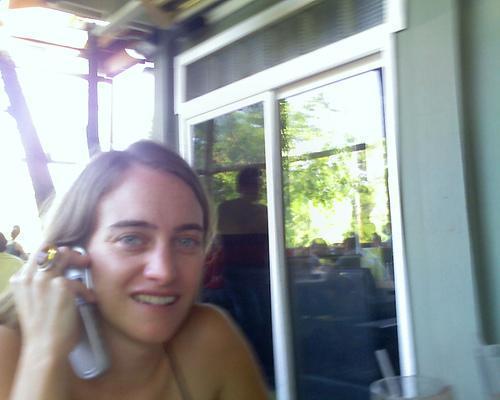Where is she most likely having a conversation on her cellphone?
Choose the right answer from the provided options to respond to the question.
Options: Street, park, restaurant, school. Restaurant. 